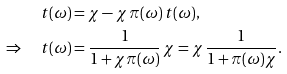<formula> <loc_0><loc_0><loc_500><loc_500>t ( \omega ) & = \chi - \chi \, \pi ( \omega ) \, t ( \omega ) , \\ \Rightarrow \quad t ( \omega ) & = \frac { 1 } { 1 + \chi \pi ( \omega ) } \, \chi = \chi \, \frac { 1 } { 1 + \pi ( \omega ) \chi } .</formula> 